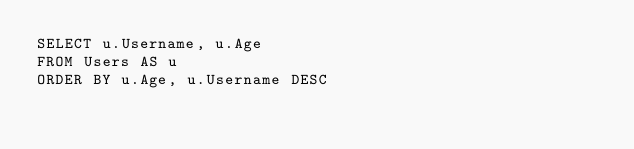<code> <loc_0><loc_0><loc_500><loc_500><_SQL_>SELECT u.Username, u.Age 
FROM Users AS u 
ORDER BY u.Age, u.Username DESC</code> 